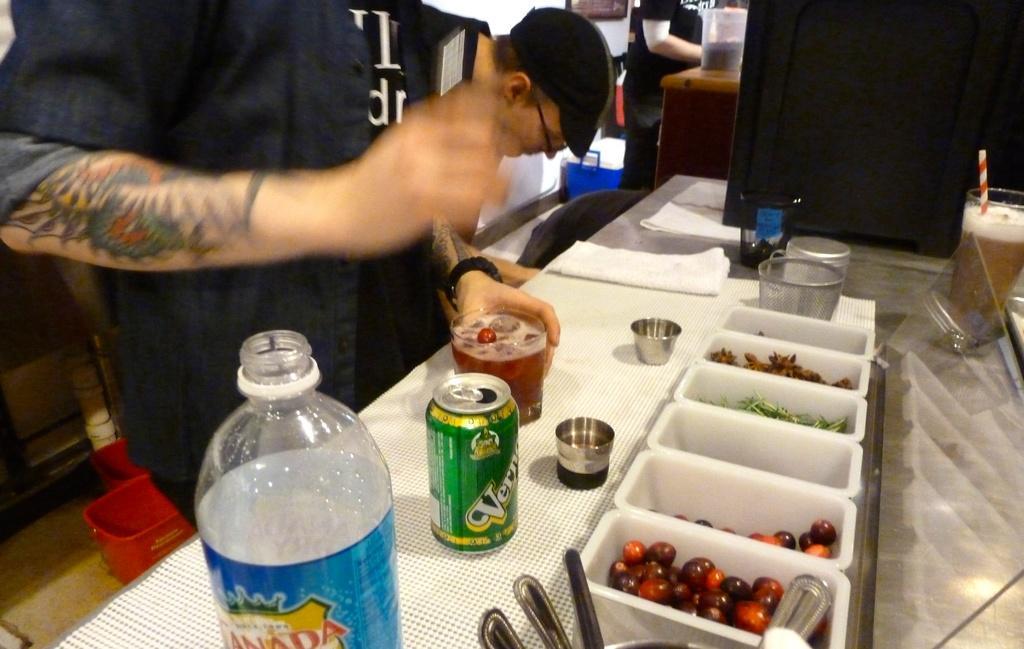Could you give a brief overview of what you see in this image? There is a water bottle,tin,glass of drink,small cups,spoons and small boxes containing food in it on a table. Beside it there are few people. 